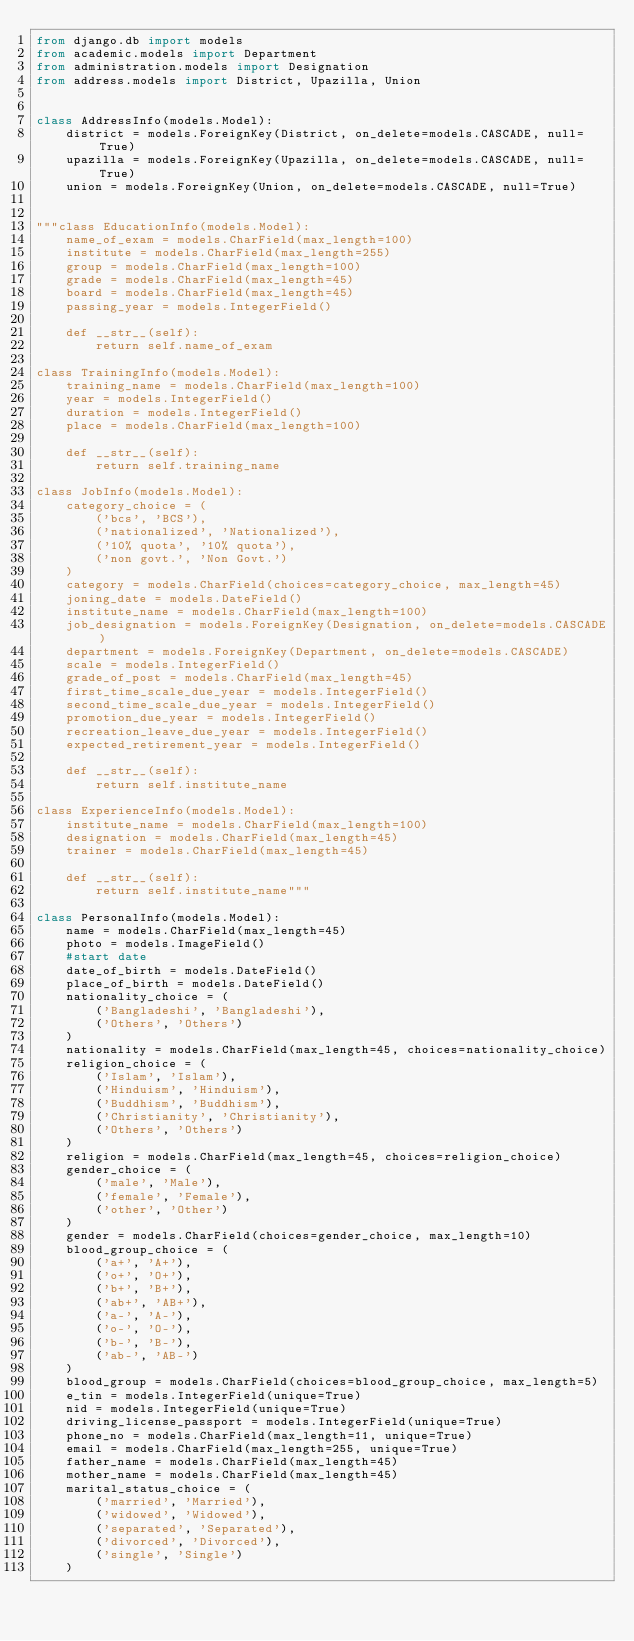Convert code to text. <code><loc_0><loc_0><loc_500><loc_500><_Python_>from django.db import models
from academic.models import Department
from administration.models import Designation
from address.models import District, Upazilla, Union


class AddressInfo(models.Model):
    district = models.ForeignKey(District, on_delete=models.CASCADE, null=True)
    upazilla = models.ForeignKey(Upazilla, on_delete=models.CASCADE, null=True)
    union = models.ForeignKey(Union, on_delete=models.CASCADE, null=True)


"""class EducationInfo(models.Model):
    name_of_exam = models.CharField(max_length=100)
    institute = models.CharField(max_length=255)
    group = models.CharField(max_length=100)
    grade = models.CharField(max_length=45)
    board = models.CharField(max_length=45)
    passing_year = models.IntegerField()

    def __str__(self):
        return self.name_of_exam

class TrainingInfo(models.Model):
    training_name = models.CharField(max_length=100)
    year = models.IntegerField()
    duration = models.IntegerField()
    place = models.CharField(max_length=100)

    def __str__(self):
        return self.training_name

class JobInfo(models.Model):
    category_choice = (
        ('bcs', 'BCS'),
        ('nationalized', 'Nationalized'),
        ('10% quota', '10% quota'),
        ('non govt.', 'Non Govt.')
    )
    category = models.CharField(choices=category_choice, max_length=45)
    joning_date = models.DateField()
    institute_name = models.CharField(max_length=100)
    job_designation = models.ForeignKey(Designation, on_delete=models.CASCADE)
    department = models.ForeignKey(Department, on_delete=models.CASCADE)
    scale = models.IntegerField()
    grade_of_post = models.CharField(max_length=45)
    first_time_scale_due_year = models.IntegerField()
    second_time_scale_due_year = models.IntegerField()
    promotion_due_year = models.IntegerField()
    recreation_leave_due_year = models.IntegerField()
    expected_retirement_year = models.IntegerField()

    def __str__(self):
        return self.institute_name

class ExperienceInfo(models.Model):
    institute_name = models.CharField(max_length=100)
    designation = models.CharField(max_length=45)
    trainer = models.CharField(max_length=45)

    def __str__(self):
        return self.institute_name"""

class PersonalInfo(models.Model):
    name = models.CharField(max_length=45)
    photo = models.ImageField()
    #start date
    date_of_birth = models.DateField()
    place_of_birth = models.DateField()
    nationality_choice = (
        ('Bangladeshi', 'Bangladeshi'),
        ('Others', 'Others')
    )
    nationality = models.CharField(max_length=45, choices=nationality_choice)
    religion_choice = (
        ('Islam', 'Islam'),
        ('Hinduism', 'Hinduism'),
        ('Buddhism', 'Buddhism'),
        ('Christianity', 'Christianity'),
        ('Others', 'Others')
    )
    religion = models.CharField(max_length=45, choices=religion_choice)
    gender_choice = (
        ('male', 'Male'),
        ('female', 'Female'),
        ('other', 'Other')
    )
    gender = models.CharField(choices=gender_choice, max_length=10)
    blood_group_choice = (
        ('a+', 'A+'),
        ('o+', 'O+'),
        ('b+', 'B+'),
        ('ab+', 'AB+'),
        ('a-', 'A-'),
        ('o-', 'O-'),
        ('b-', 'B-'),
        ('ab-', 'AB-')
    )
    blood_group = models.CharField(choices=blood_group_choice, max_length=5)
    e_tin = models.IntegerField(unique=True)
    nid = models.IntegerField(unique=True)
    driving_license_passport = models.IntegerField(unique=True)
    phone_no = models.CharField(max_length=11, unique=True)
    email = models.CharField(max_length=255, unique=True)
    father_name = models.CharField(max_length=45)
    mother_name = models.CharField(max_length=45)
    marital_status_choice = (
        ('married', 'Married'),
        ('widowed', 'Widowed'),
        ('separated', 'Separated'),
        ('divorced', 'Divorced'),
        ('single', 'Single')
    )</code> 